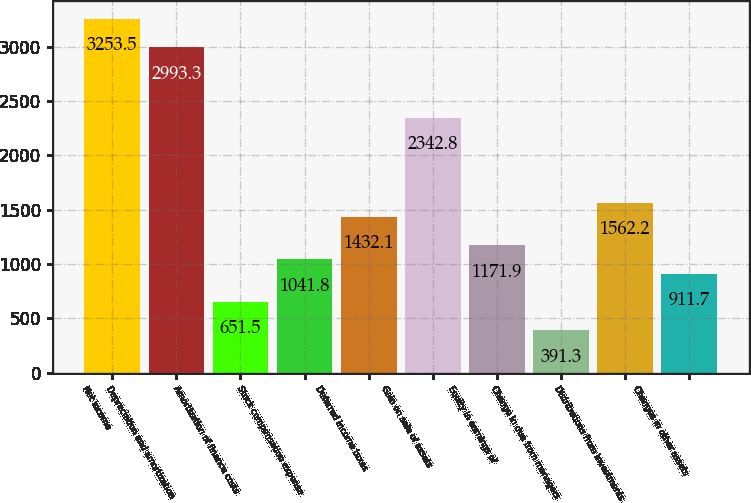Convert chart. <chart><loc_0><loc_0><loc_500><loc_500><bar_chart><fcel>Net income<fcel>Depreciation and amortization<fcel>Amortization of finance costs<fcel>Stock compensation expense<fcel>Deferred income taxes<fcel>Gain on sale of assets<fcel>Equity in earnings of<fcel>Change in due from managers<fcel>Distributions from investments<fcel>Changes in other assets<nl><fcel>3253.5<fcel>2993.3<fcel>651.5<fcel>1041.8<fcel>1432.1<fcel>2342.8<fcel>1171.9<fcel>391.3<fcel>1562.2<fcel>911.7<nl></chart> 